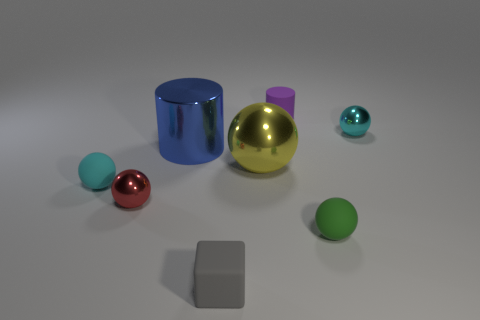How does the light interact with the objects of different materials? The light produces distinct reflections and shadows on each object, highlighting their textures and shapes. The metallic surfaces reflect light more sharply, while the rubber balls have softer reflections and diffused shadows. Which object seems to reflect the most light? The golden ball reflects the most light, given its highly reflective metallic surface and spherical shape which acts as a mirror in every direction. 